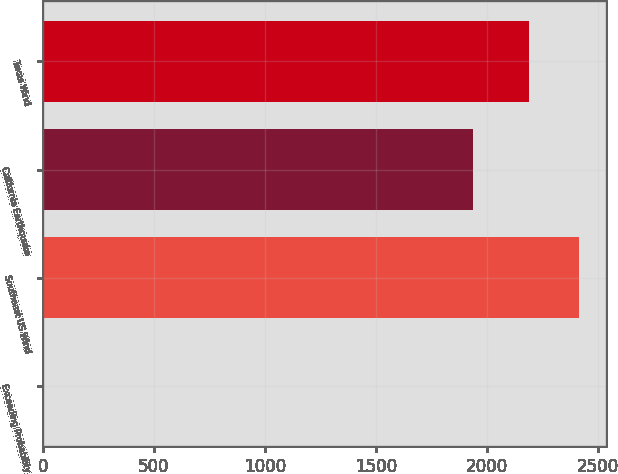Convert chart. <chart><loc_0><loc_0><loc_500><loc_500><bar_chart><fcel>Exceeding Probability<fcel>Southeast US Wind<fcel>California Earthquake<fcel>Texas Wind<nl><fcel>0.1<fcel>2415.79<fcel>1939<fcel>2190<nl></chart> 